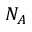Convert formula to latex. <formula><loc_0><loc_0><loc_500><loc_500>N _ { A }</formula> 